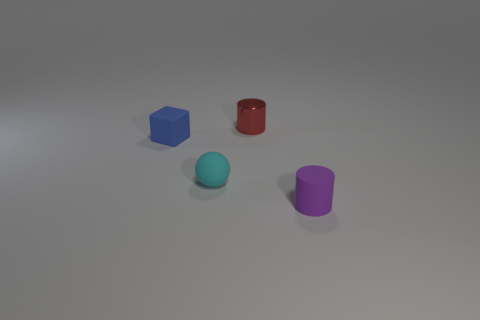What are the different shapes and colors present in the image? The image displays an assortment of four objects consisting of a tiny blue cube, a tiny matte cyan sphere, a glossy red cylinder, and a matte purple cylinder placed on a grey surface with a neutral background. 